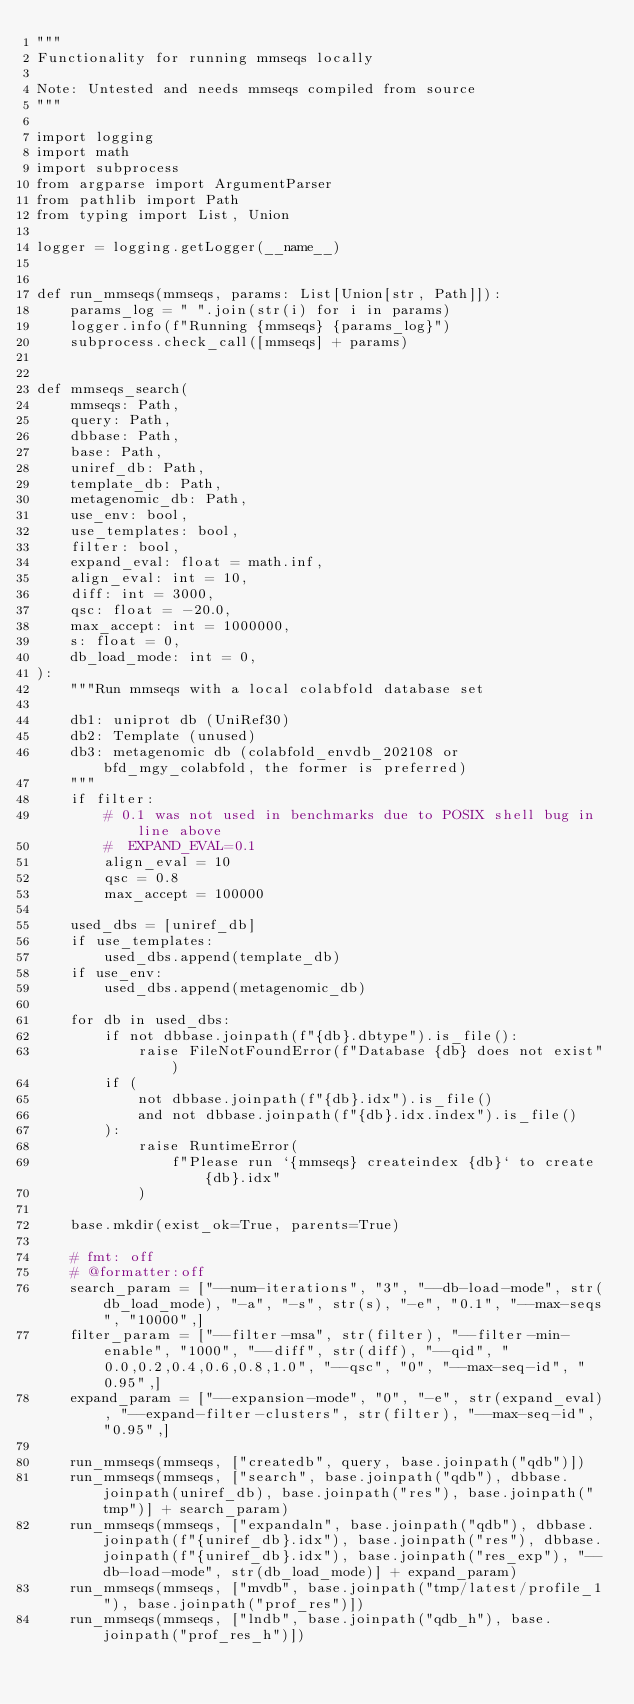Convert code to text. <code><loc_0><loc_0><loc_500><loc_500><_Python_>"""
Functionality for running mmseqs locally

Note: Untested and needs mmseqs compiled from source
"""

import logging
import math
import subprocess
from argparse import ArgumentParser
from pathlib import Path
from typing import List, Union

logger = logging.getLogger(__name__)


def run_mmseqs(mmseqs, params: List[Union[str, Path]]):
    params_log = " ".join(str(i) for i in params)
    logger.info(f"Running {mmseqs} {params_log}")
    subprocess.check_call([mmseqs] + params)


def mmseqs_search(
    mmseqs: Path,
    query: Path,
    dbbase: Path,
    base: Path,
    uniref_db: Path,
    template_db: Path,
    metagenomic_db: Path,
    use_env: bool,
    use_templates: bool,
    filter: bool,
    expand_eval: float = math.inf,
    align_eval: int = 10,
    diff: int = 3000,
    qsc: float = -20.0,
    max_accept: int = 1000000,
    s: float = 0,
    db_load_mode: int = 0,
):
    """Run mmseqs with a local colabfold database set

    db1: uniprot db (UniRef30)
    db2: Template (unused)
    db3: metagenomic db (colabfold_envdb_202108 or bfd_mgy_colabfold, the former is preferred)
    """
    if filter:
        # 0.1 was not used in benchmarks due to POSIX shell bug in line above
        #  EXPAND_EVAL=0.1
        align_eval = 10
        qsc = 0.8
        max_accept = 100000

    used_dbs = [uniref_db]
    if use_templates:
        used_dbs.append(template_db)
    if use_env:
        used_dbs.append(metagenomic_db)

    for db in used_dbs:
        if not dbbase.joinpath(f"{db}.dbtype").is_file():
            raise FileNotFoundError(f"Database {db} does not exist")
        if (
            not dbbase.joinpath(f"{db}.idx").is_file()
            and not dbbase.joinpath(f"{db}.idx.index").is_file()
        ):
            raise RuntimeError(
                f"Please run `{mmseqs} createindex {db}` to create {db}.idx"
            )

    base.mkdir(exist_ok=True, parents=True)

    # fmt: off
    # @formatter:off
    search_param = ["--num-iterations", "3", "--db-load-mode", str(db_load_mode), "-a", "-s", str(s), "-e", "0.1", "--max-seqs", "10000",]
    filter_param = ["--filter-msa", str(filter), "--filter-min-enable", "1000", "--diff", str(diff), "--qid", "0.0,0.2,0.4,0.6,0.8,1.0", "--qsc", "0", "--max-seq-id", "0.95",]
    expand_param = ["--expansion-mode", "0", "-e", str(expand_eval), "--expand-filter-clusters", str(filter), "--max-seq-id", "0.95",]

    run_mmseqs(mmseqs, ["createdb", query, base.joinpath("qdb")])
    run_mmseqs(mmseqs, ["search", base.joinpath("qdb"), dbbase.joinpath(uniref_db), base.joinpath("res"), base.joinpath("tmp")] + search_param)
    run_mmseqs(mmseqs, ["expandaln", base.joinpath("qdb"), dbbase.joinpath(f"{uniref_db}.idx"), base.joinpath("res"), dbbase.joinpath(f"{uniref_db}.idx"), base.joinpath("res_exp"), "--db-load-mode", str(db_load_mode)] + expand_param)
    run_mmseqs(mmseqs, ["mvdb", base.joinpath("tmp/latest/profile_1"), base.joinpath("prof_res")])
    run_mmseqs(mmseqs, ["lndb", base.joinpath("qdb_h"), base.joinpath("prof_res_h")])</code> 